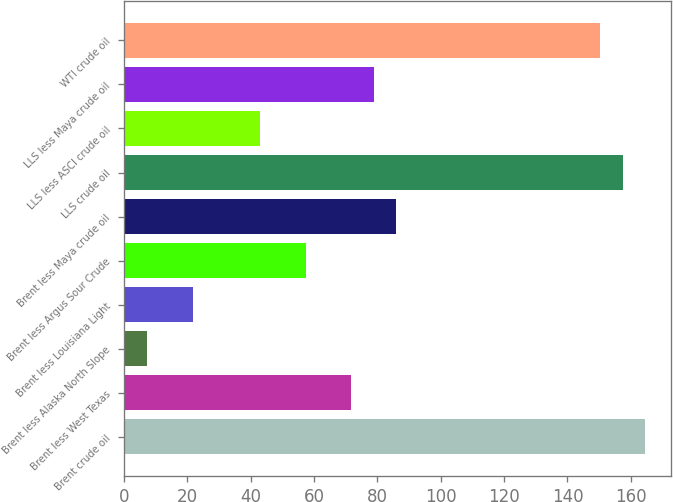Convert chart to OTSL. <chart><loc_0><loc_0><loc_500><loc_500><bar_chart><fcel>Brent crude oil<fcel>Brent less West Texas<fcel>Brent less Alaska North Slope<fcel>Brent less Louisiana Light<fcel>Brent less Argus Sour Crude<fcel>Brent less Maya crude oil<fcel>LLS crude oil<fcel>LLS less ASCI crude oil<fcel>LLS less Maya crude oil<fcel>WTI crude oil<nl><fcel>164.6<fcel>71.65<fcel>7.3<fcel>21.6<fcel>57.35<fcel>85.95<fcel>157.45<fcel>43.05<fcel>78.8<fcel>150.3<nl></chart> 